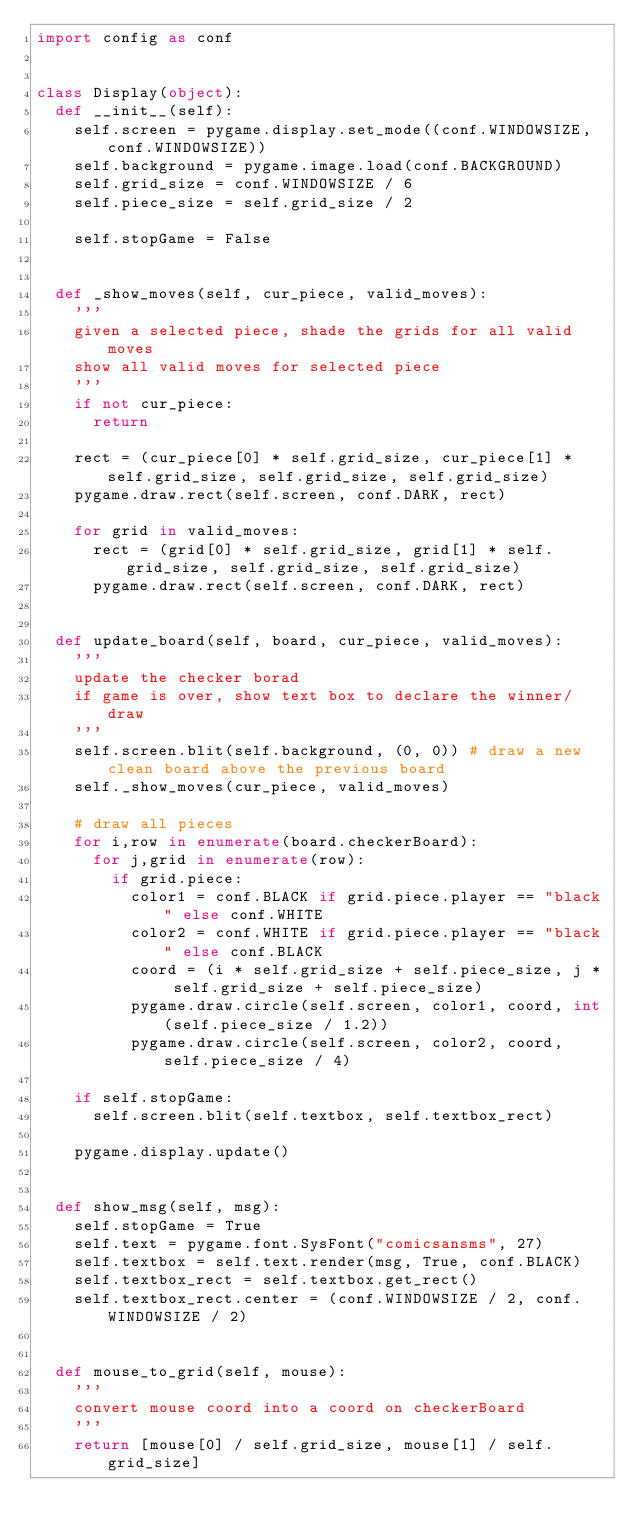<code> <loc_0><loc_0><loc_500><loc_500><_Python_>import config as conf


class Display(object):
	def __init__(self):
		self.screen = pygame.display.set_mode((conf.WINDOWSIZE, conf.WINDOWSIZE))
		self.background = pygame.image.load(conf.BACKGROUND)
		self.grid_size = conf.WINDOWSIZE / 6
		self.piece_size = self.grid_size / 2

		self.stopGame = False


	def _show_moves(self, cur_piece, valid_moves):
		'''
		given a selected piece, shade the grids for all valid moves
		show all valid moves for selected piece
		'''
		if not cur_piece:
			return

		rect = (cur_piece[0] * self.grid_size, cur_piece[1] * self.grid_size, self.grid_size, self.grid_size)
		pygame.draw.rect(self.screen, conf.DARK, rect)

		for grid in valid_moves:
			rect = (grid[0] * self.grid_size, grid[1] * self.grid_size, self.grid_size, self.grid_size)
			pygame.draw.rect(self.screen, conf.DARK, rect)
	

	def update_board(self, board, cur_piece, valid_moves):
		'''
		update the checker borad
		if game is over, show text box to declare the winner/draw
		'''
		self.screen.blit(self.background, (0, 0))	# draw a new clean board above the previous board
		self._show_moves(cur_piece, valid_moves)
		
		# draw all pieces
		for i,row in enumerate(board.checkerBoard):
			for j,grid in enumerate(row):
				if grid.piece:
					color1 = conf.BLACK if grid.piece.player == "black" else conf.WHITE
					color2 = conf.WHITE if grid.piece.player == "black" else conf.BLACK
					coord = (i * self.grid_size + self.piece_size, j * self.grid_size + self.piece_size)
					pygame.draw.circle(self.screen, color1, coord, int(self.piece_size / 1.2))
					pygame.draw.circle(self.screen, color2, coord, self.piece_size / 4)

		if self.stopGame:
			self.screen.blit(self.textbox, self.textbox_rect)

		pygame.display.update()


	def show_msg(self, msg):
		self.stopGame = True
		self.text = pygame.font.SysFont("comicsansms", 27)
		self.textbox = self.text.render(msg, True, conf.BLACK)
		self.textbox_rect = self.textbox.get_rect()
		self.textbox_rect.center = (conf.WINDOWSIZE / 2, conf.WINDOWSIZE / 2)

	
	def mouse_to_grid(self, mouse):
		'''
		convert mouse coord into a coord on checkerBoard
		'''
		return [mouse[0] / self.grid_size, mouse[1] / self.grid_size]







</code> 